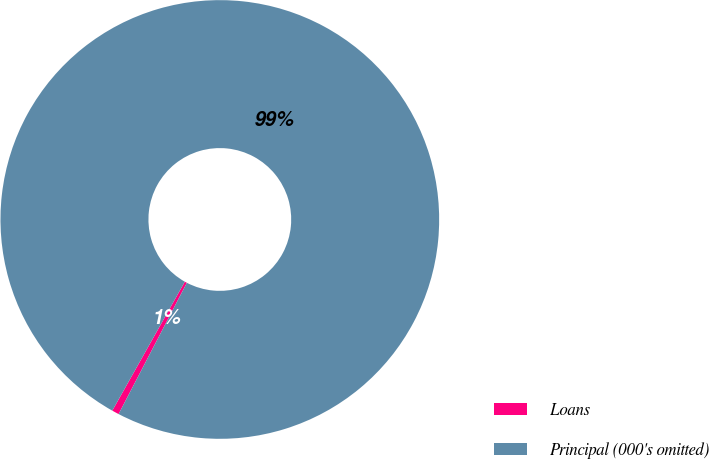<chart> <loc_0><loc_0><loc_500><loc_500><pie_chart><fcel>Loans<fcel>Principal (000's omitted)<nl><fcel>0.52%<fcel>99.48%<nl></chart> 